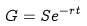Convert formula to latex. <formula><loc_0><loc_0><loc_500><loc_500>G = S e ^ { - r t }</formula> 